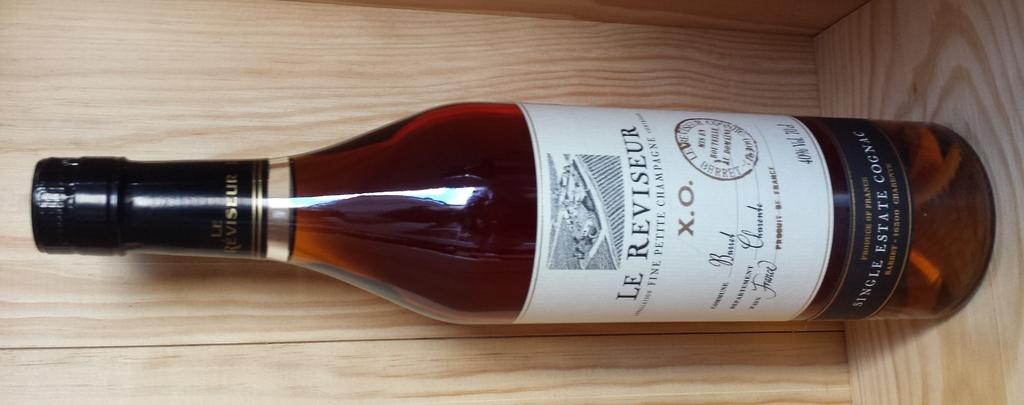Provide a one-sentence caption for the provided image. A bottle of Le Reviseur Fine Petite Champagne is shown sideways on wooden surface. 